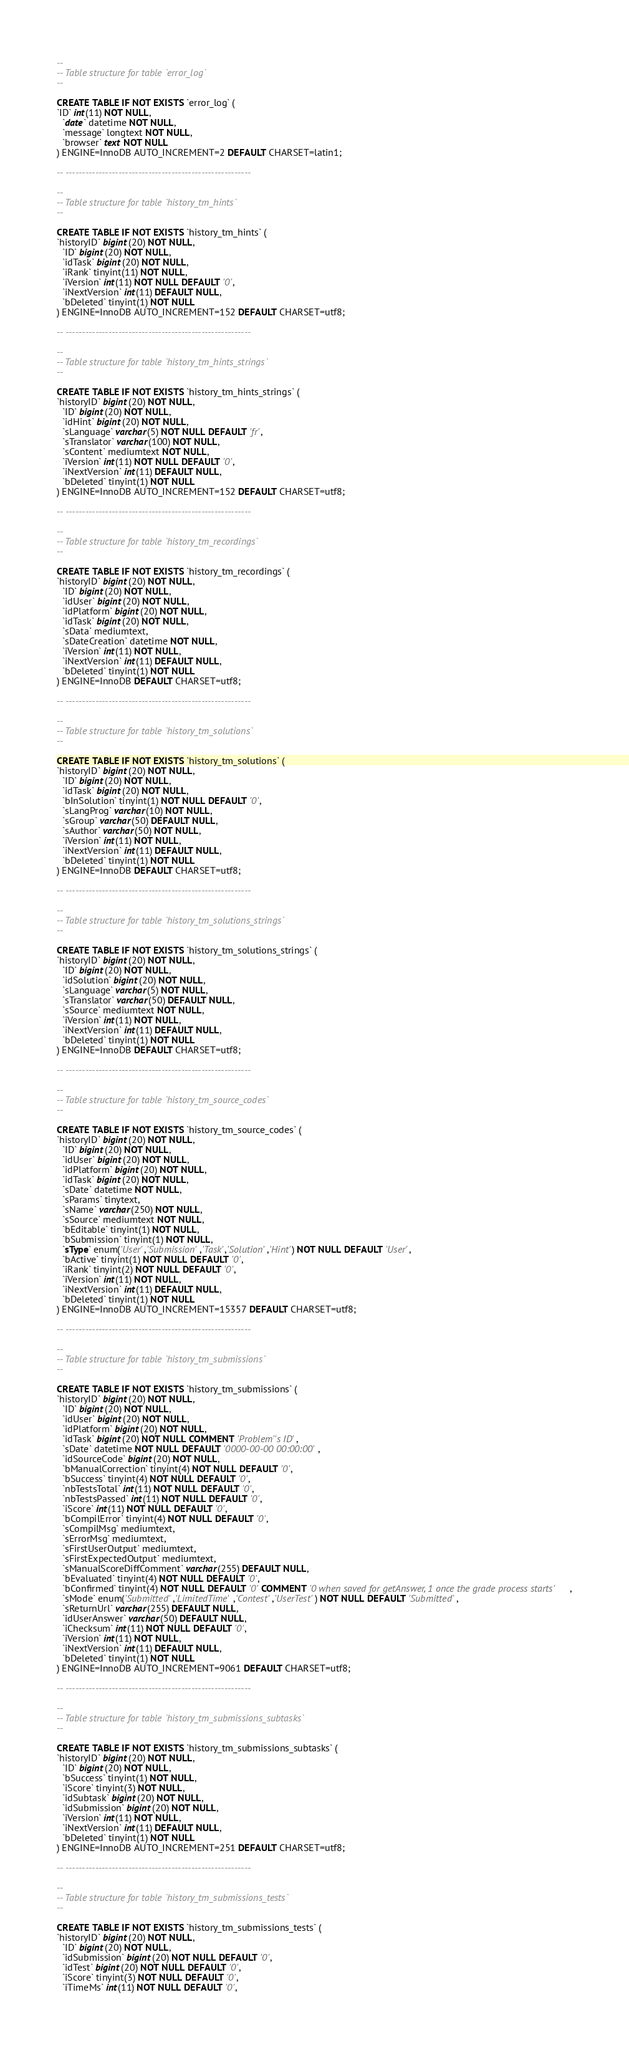Convert code to text. <code><loc_0><loc_0><loc_500><loc_500><_SQL_>--
-- Table structure for table `error_log`
--

CREATE TABLE IF NOT EXISTS `error_log` (
`ID` int(11) NOT NULL,
  `date` datetime NOT NULL,
  `message` longtext NOT NULL,
  `browser` text NOT NULL
) ENGINE=InnoDB AUTO_INCREMENT=2 DEFAULT CHARSET=latin1;

-- --------------------------------------------------------

--
-- Table structure for table `history_tm_hints`
--

CREATE TABLE IF NOT EXISTS `history_tm_hints` (
`historyID` bigint(20) NOT NULL,
  `ID` bigint(20) NOT NULL,
  `idTask` bigint(20) NOT NULL,
  `iRank` tinyint(11) NOT NULL,
  `iVersion` int(11) NOT NULL DEFAULT '0',
  `iNextVersion` int(11) DEFAULT NULL,
  `bDeleted` tinyint(1) NOT NULL
) ENGINE=InnoDB AUTO_INCREMENT=152 DEFAULT CHARSET=utf8;

-- --------------------------------------------------------

--
-- Table structure for table `history_tm_hints_strings`
--

CREATE TABLE IF NOT EXISTS `history_tm_hints_strings` (
`historyID` bigint(20) NOT NULL,
  `ID` bigint(20) NOT NULL,
  `idHint` bigint(20) NOT NULL,
  `sLanguage` varchar(5) NOT NULL DEFAULT 'fr',
  `sTranslator` varchar(100) NOT NULL,
  `sContent` mediumtext NOT NULL,
  `iVersion` int(11) NOT NULL DEFAULT '0',
  `iNextVersion` int(11) DEFAULT NULL,
  `bDeleted` tinyint(1) NOT NULL
) ENGINE=InnoDB AUTO_INCREMENT=152 DEFAULT CHARSET=utf8;

-- --------------------------------------------------------

--
-- Table structure for table `history_tm_recordings`
--

CREATE TABLE IF NOT EXISTS `history_tm_recordings` (
`historyID` bigint(20) NOT NULL,
  `ID` bigint(20) NOT NULL,
  `idUser` bigint(20) NOT NULL,
  `idPlatform` bigint(20) NOT NULL,
  `idTask` bigint(20) NOT NULL,
  `sData` mediumtext,
  `sDateCreation` datetime NOT NULL,
  `iVersion` int(11) NOT NULL,
  `iNextVersion` int(11) DEFAULT NULL,
  `bDeleted` tinyint(1) NOT NULL
) ENGINE=InnoDB DEFAULT CHARSET=utf8;

-- --------------------------------------------------------

--
-- Table structure for table `history_tm_solutions`
--

CREATE TABLE IF NOT EXISTS `history_tm_solutions` (
`historyID` bigint(20) NOT NULL,
  `ID` bigint(20) NOT NULL,
  `idTask` bigint(20) NOT NULL,
  `bInSolution` tinyint(1) NOT NULL DEFAULT '0',
  `sLangProg` varchar(10) NOT NULL,
  `sGroup` varchar(50) DEFAULT NULL,
  `sAuthor` varchar(50) NOT NULL,
  `iVersion` int(11) NOT NULL,
  `iNextVersion` int(11) DEFAULT NULL,
  `bDeleted` tinyint(1) NOT NULL
) ENGINE=InnoDB DEFAULT CHARSET=utf8;

-- --------------------------------------------------------

--
-- Table structure for table `history_tm_solutions_strings`
--

CREATE TABLE IF NOT EXISTS `history_tm_solutions_strings` (
`historyID` bigint(20) NOT NULL,
  `ID` bigint(20) NOT NULL,
  `idSolution` bigint(20) NOT NULL,
  `sLanguage` varchar(5) NOT NULL,
  `sTranslator` varchar(50) DEFAULT NULL,
  `sSource` mediumtext NOT NULL,
  `iVersion` int(11) NOT NULL,
  `iNextVersion` int(11) DEFAULT NULL,
  `bDeleted` tinyint(1) NOT NULL
) ENGINE=InnoDB DEFAULT CHARSET=utf8;

-- --------------------------------------------------------

--
-- Table structure for table `history_tm_source_codes`
--

CREATE TABLE IF NOT EXISTS `history_tm_source_codes` (
`historyID` bigint(20) NOT NULL,
  `ID` bigint(20) NOT NULL,
  `idUser` bigint(20) NOT NULL,
  `idPlatform` bigint(20) NOT NULL,
  `idTask` bigint(20) NOT NULL,
  `sDate` datetime NOT NULL,
  `sParams` tinytext,
  `sName` varchar(250) NOT NULL,
  `sSource` mediumtext NOT NULL,
  `bEditable` tinyint(1) NOT NULL,
  `bSubmission` tinyint(1) NOT NULL,
  `sType` enum('User','Submission','Task','Solution','Hint') NOT NULL DEFAULT 'User',
  `bActive` tinyint(1) NOT NULL DEFAULT '0',
  `iRank` tinyint(2) NOT NULL DEFAULT '0',
  `iVersion` int(11) NOT NULL,
  `iNextVersion` int(11) DEFAULT NULL,
  `bDeleted` tinyint(1) NOT NULL
) ENGINE=InnoDB AUTO_INCREMENT=15357 DEFAULT CHARSET=utf8;

-- --------------------------------------------------------

--
-- Table structure for table `history_tm_submissions`
--

CREATE TABLE IF NOT EXISTS `history_tm_submissions` (
`historyID` bigint(20) NOT NULL,
  `ID` bigint(20) NOT NULL,
  `idUser` bigint(20) NOT NULL,
  `idPlatform` bigint(20) NOT NULL,
  `idTask` bigint(20) NOT NULL COMMENT 'Problem''s ID',
  `sDate` datetime NOT NULL DEFAULT '0000-00-00 00:00:00',
  `idSourceCode` bigint(20) NOT NULL,
  `bManualCorrection` tinyint(4) NOT NULL DEFAULT '0',
  `bSuccess` tinyint(4) NOT NULL DEFAULT '0',
  `nbTestsTotal` int(11) NOT NULL DEFAULT '0',
  `nbTestsPassed` int(11) NOT NULL DEFAULT '0',
  `iScore` int(11) NOT NULL DEFAULT '0',
  `bCompilError` tinyint(4) NOT NULL DEFAULT '0',
  `sCompilMsg` mediumtext,
  `sErrorMsg` mediumtext,
  `sFirstUserOutput` mediumtext,
  `sFirstExpectedOutput` mediumtext,
  `sManualScoreDiffComment` varchar(255) DEFAULT NULL,
  `bEvaluated` tinyint(4) NOT NULL DEFAULT '0',
  `bConfirmed` tinyint(4) NOT NULL DEFAULT '0' COMMENT '0 when saved for getAnswer, 1 once the grade process starts',
  `sMode` enum('Submitted','LimitedTime','Contest','UserTest') NOT NULL DEFAULT 'Submitted',
  `sReturnUrl` varchar(255) DEFAULT NULL,
  `idUserAnswer` varchar(50) DEFAULT NULL,
  `iChecksum` int(11) NOT NULL DEFAULT '0',
  `iVersion` int(11) NOT NULL,
  `iNextVersion` int(11) DEFAULT NULL,
  `bDeleted` tinyint(1) NOT NULL
) ENGINE=InnoDB AUTO_INCREMENT=9061 DEFAULT CHARSET=utf8;

-- --------------------------------------------------------

--
-- Table structure for table `history_tm_submissions_subtasks`
--

CREATE TABLE IF NOT EXISTS `history_tm_submissions_subtasks` (
`historyID` bigint(20) NOT NULL,
  `ID` bigint(20) NOT NULL,
  `bSuccess` tinyint(1) NOT NULL,
  `iScore` tinyint(3) NOT NULL,
  `idSubtask` bigint(20) NOT NULL,
  `idSubmission` bigint(20) NOT NULL,
  `iVersion` int(11) NOT NULL,
  `iNextVersion` int(11) DEFAULT NULL,
  `bDeleted` tinyint(1) NOT NULL
) ENGINE=InnoDB AUTO_INCREMENT=251 DEFAULT CHARSET=utf8;

-- --------------------------------------------------------

--
-- Table structure for table `history_tm_submissions_tests`
--

CREATE TABLE IF NOT EXISTS `history_tm_submissions_tests` (
`historyID` bigint(20) NOT NULL,
  `ID` bigint(20) NOT NULL,
  `idSubmission` bigint(20) NOT NULL DEFAULT '0',
  `idTest` bigint(20) NOT NULL DEFAULT '0',
  `iScore` tinyint(3) NOT NULL DEFAULT '0',
  `iTimeMs` int(11) NOT NULL DEFAULT '0',</code> 